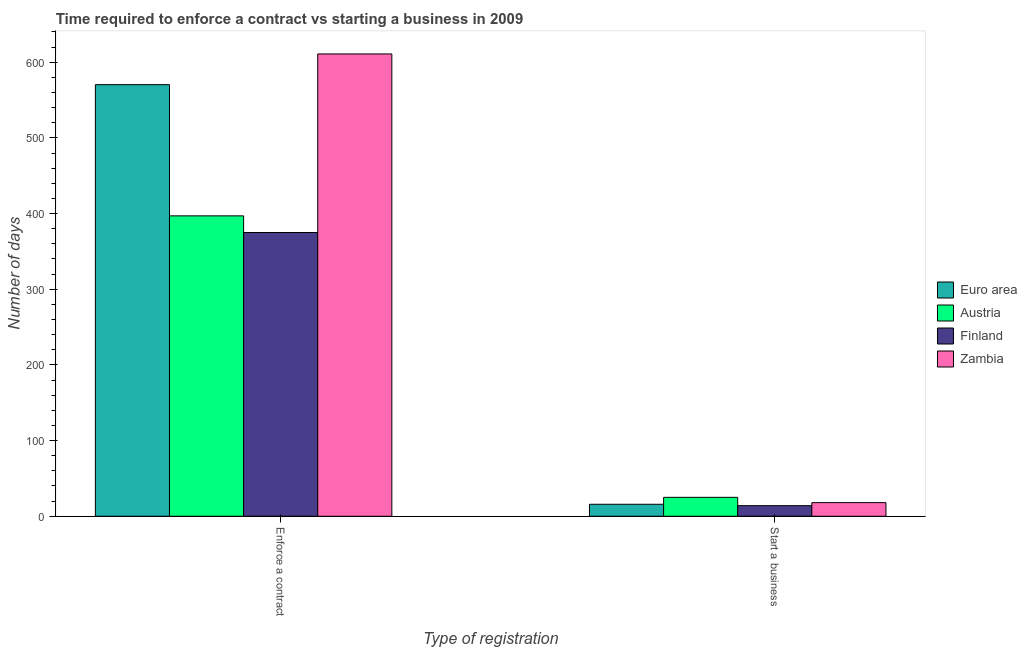How many bars are there on the 1st tick from the left?
Provide a succinct answer. 4. How many bars are there on the 1st tick from the right?
Provide a short and direct response. 4. What is the label of the 1st group of bars from the left?
Your response must be concise. Enforce a contract. What is the number of days to enforece a contract in Zambia?
Provide a succinct answer. 611. Across all countries, what is the maximum number of days to start a business?
Keep it short and to the point. 25. Across all countries, what is the minimum number of days to start a business?
Give a very brief answer. 14. In which country was the number of days to enforece a contract minimum?
Offer a very short reply. Finland. What is the total number of days to enforece a contract in the graph?
Keep it short and to the point. 1953.39. What is the difference between the number of days to start a business in Zambia and that in Finland?
Keep it short and to the point. 4. What is the difference between the number of days to enforece a contract in Finland and the number of days to start a business in Euro area?
Keep it short and to the point. 359.17. What is the average number of days to start a business per country?
Ensure brevity in your answer.  18.21. What is the difference between the number of days to start a business and number of days to enforece a contract in Euro area?
Your answer should be very brief. -554.56. In how many countries, is the number of days to enforece a contract greater than 500 days?
Offer a very short reply. 2. What is the ratio of the number of days to enforece a contract in Finland to that in Austria?
Offer a very short reply. 0.94. What does the 1st bar from the right in Enforce a contract represents?
Your answer should be very brief. Zambia. Are the values on the major ticks of Y-axis written in scientific E-notation?
Your answer should be compact. No. How are the legend labels stacked?
Make the answer very short. Vertical. What is the title of the graph?
Offer a terse response. Time required to enforce a contract vs starting a business in 2009. Does "Turkmenistan" appear as one of the legend labels in the graph?
Give a very brief answer. No. What is the label or title of the X-axis?
Your answer should be very brief. Type of registration. What is the label or title of the Y-axis?
Offer a terse response. Number of days. What is the Number of days of Euro area in Enforce a contract?
Offer a terse response. 570.39. What is the Number of days of Austria in Enforce a contract?
Your answer should be compact. 397. What is the Number of days in Finland in Enforce a contract?
Ensure brevity in your answer.  375. What is the Number of days of Zambia in Enforce a contract?
Offer a very short reply. 611. What is the Number of days in Euro area in Start a business?
Make the answer very short. 15.83. What is the Number of days in Austria in Start a business?
Give a very brief answer. 25. Across all Type of registration, what is the maximum Number of days in Euro area?
Provide a succinct answer. 570.39. Across all Type of registration, what is the maximum Number of days of Austria?
Your answer should be compact. 397. Across all Type of registration, what is the maximum Number of days in Finland?
Your answer should be very brief. 375. Across all Type of registration, what is the maximum Number of days of Zambia?
Ensure brevity in your answer.  611. Across all Type of registration, what is the minimum Number of days in Euro area?
Ensure brevity in your answer.  15.83. Across all Type of registration, what is the minimum Number of days of Finland?
Offer a terse response. 14. Across all Type of registration, what is the minimum Number of days in Zambia?
Ensure brevity in your answer.  18. What is the total Number of days of Euro area in the graph?
Provide a short and direct response. 586.22. What is the total Number of days in Austria in the graph?
Your response must be concise. 422. What is the total Number of days of Finland in the graph?
Provide a succinct answer. 389. What is the total Number of days in Zambia in the graph?
Make the answer very short. 629. What is the difference between the Number of days of Euro area in Enforce a contract and that in Start a business?
Offer a very short reply. 554.56. What is the difference between the Number of days of Austria in Enforce a contract and that in Start a business?
Your answer should be very brief. 372. What is the difference between the Number of days in Finland in Enforce a contract and that in Start a business?
Offer a terse response. 361. What is the difference between the Number of days in Zambia in Enforce a contract and that in Start a business?
Provide a short and direct response. 593. What is the difference between the Number of days of Euro area in Enforce a contract and the Number of days of Austria in Start a business?
Make the answer very short. 545.39. What is the difference between the Number of days in Euro area in Enforce a contract and the Number of days in Finland in Start a business?
Your response must be concise. 556.39. What is the difference between the Number of days in Euro area in Enforce a contract and the Number of days in Zambia in Start a business?
Your answer should be very brief. 552.39. What is the difference between the Number of days in Austria in Enforce a contract and the Number of days in Finland in Start a business?
Your answer should be compact. 383. What is the difference between the Number of days in Austria in Enforce a contract and the Number of days in Zambia in Start a business?
Ensure brevity in your answer.  379. What is the difference between the Number of days in Finland in Enforce a contract and the Number of days in Zambia in Start a business?
Your response must be concise. 357. What is the average Number of days of Euro area per Type of registration?
Offer a very short reply. 293.11. What is the average Number of days in Austria per Type of registration?
Keep it short and to the point. 211. What is the average Number of days of Finland per Type of registration?
Make the answer very short. 194.5. What is the average Number of days in Zambia per Type of registration?
Keep it short and to the point. 314.5. What is the difference between the Number of days in Euro area and Number of days in Austria in Enforce a contract?
Your answer should be compact. 173.39. What is the difference between the Number of days in Euro area and Number of days in Finland in Enforce a contract?
Your response must be concise. 195.39. What is the difference between the Number of days in Euro area and Number of days in Zambia in Enforce a contract?
Your answer should be compact. -40.61. What is the difference between the Number of days of Austria and Number of days of Zambia in Enforce a contract?
Offer a very short reply. -214. What is the difference between the Number of days in Finland and Number of days in Zambia in Enforce a contract?
Ensure brevity in your answer.  -236. What is the difference between the Number of days in Euro area and Number of days in Austria in Start a business?
Give a very brief answer. -9.17. What is the difference between the Number of days in Euro area and Number of days in Finland in Start a business?
Give a very brief answer. 1.83. What is the difference between the Number of days of Euro area and Number of days of Zambia in Start a business?
Keep it short and to the point. -2.17. What is the difference between the Number of days of Austria and Number of days of Finland in Start a business?
Offer a terse response. 11. What is the difference between the Number of days in Finland and Number of days in Zambia in Start a business?
Provide a succinct answer. -4. What is the ratio of the Number of days of Euro area in Enforce a contract to that in Start a business?
Your answer should be compact. 36.02. What is the ratio of the Number of days in Austria in Enforce a contract to that in Start a business?
Your answer should be compact. 15.88. What is the ratio of the Number of days of Finland in Enforce a contract to that in Start a business?
Your response must be concise. 26.79. What is the ratio of the Number of days of Zambia in Enforce a contract to that in Start a business?
Give a very brief answer. 33.94. What is the difference between the highest and the second highest Number of days of Euro area?
Provide a short and direct response. 554.56. What is the difference between the highest and the second highest Number of days in Austria?
Provide a succinct answer. 372. What is the difference between the highest and the second highest Number of days of Finland?
Provide a short and direct response. 361. What is the difference between the highest and the second highest Number of days of Zambia?
Keep it short and to the point. 593. What is the difference between the highest and the lowest Number of days of Euro area?
Make the answer very short. 554.56. What is the difference between the highest and the lowest Number of days in Austria?
Your answer should be very brief. 372. What is the difference between the highest and the lowest Number of days of Finland?
Give a very brief answer. 361. What is the difference between the highest and the lowest Number of days in Zambia?
Provide a short and direct response. 593. 